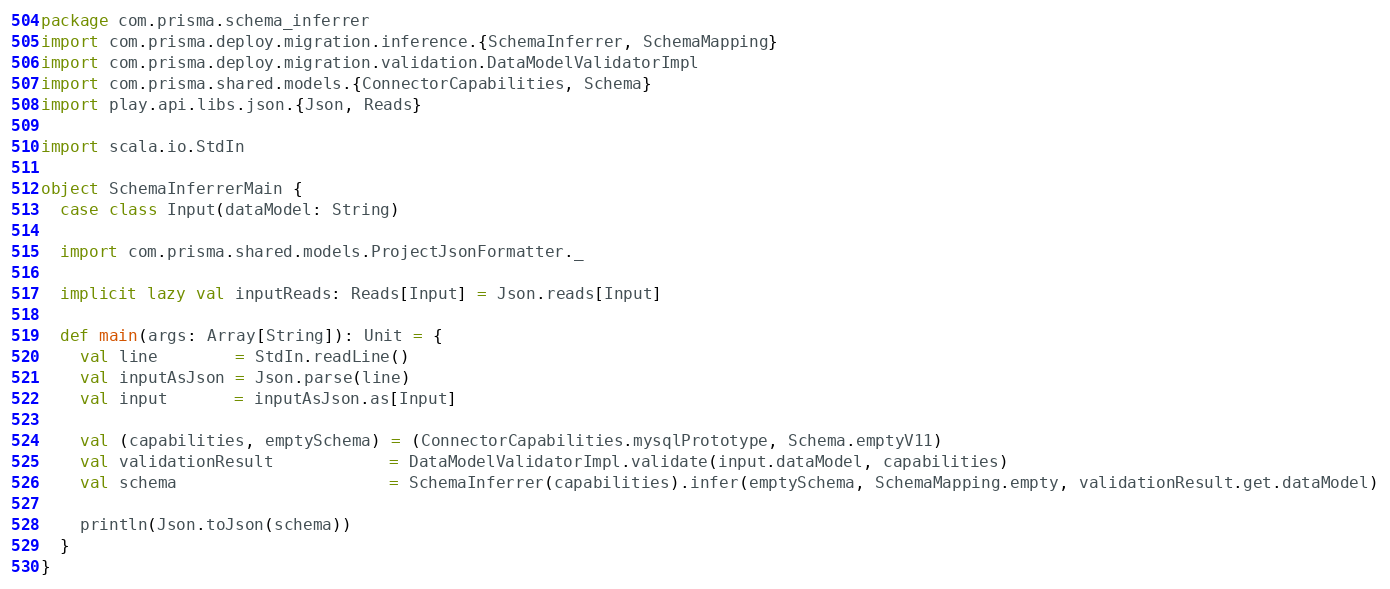Convert code to text. <code><loc_0><loc_0><loc_500><loc_500><_Scala_>package com.prisma.schema_inferrer
import com.prisma.deploy.migration.inference.{SchemaInferrer, SchemaMapping}
import com.prisma.deploy.migration.validation.DataModelValidatorImpl
import com.prisma.shared.models.{ConnectorCapabilities, Schema}
import play.api.libs.json.{Json, Reads}

import scala.io.StdIn

object SchemaInferrerMain {
  case class Input(dataModel: String)

  import com.prisma.shared.models.ProjectJsonFormatter._

  implicit lazy val inputReads: Reads[Input] = Json.reads[Input]

  def main(args: Array[String]): Unit = {
    val line        = StdIn.readLine()
    val inputAsJson = Json.parse(line)
    val input       = inputAsJson.as[Input]

    val (capabilities, emptySchema) = (ConnectorCapabilities.mysqlPrototype, Schema.emptyV11)
    val validationResult            = DataModelValidatorImpl.validate(input.dataModel, capabilities)
    val schema                      = SchemaInferrer(capabilities).infer(emptySchema, SchemaMapping.empty, validationResult.get.dataModel)

    println(Json.toJson(schema))
  }
}
</code> 